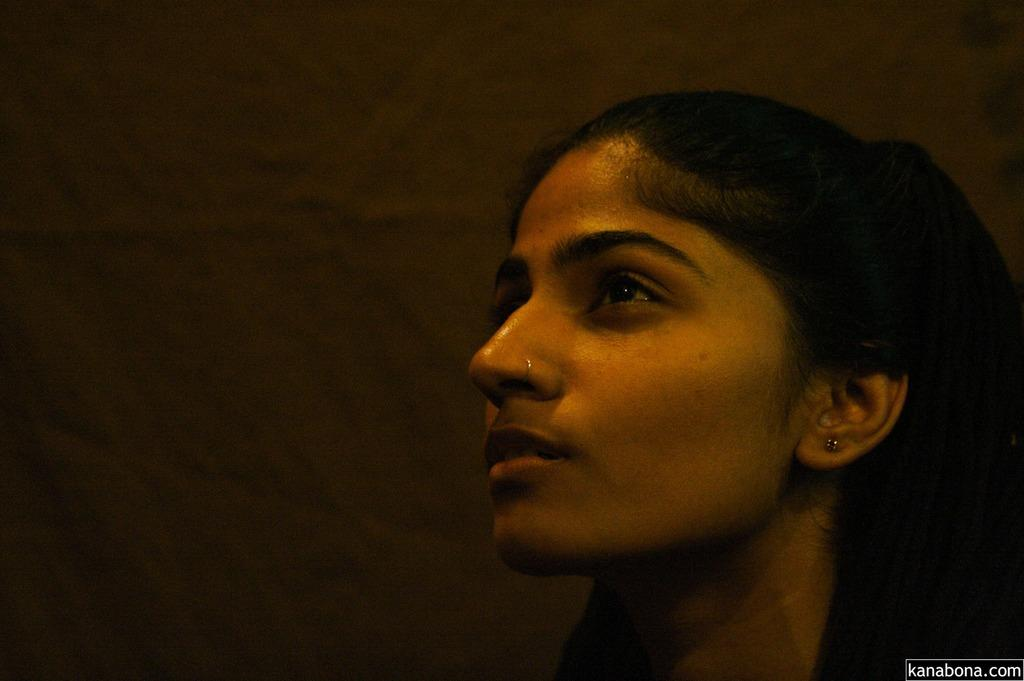Who is present in the image? There is a woman in the image. How many sisters does the woman in the image have? There is no information about the woman's sisters in the image, so it cannot be determined from the image alone. 